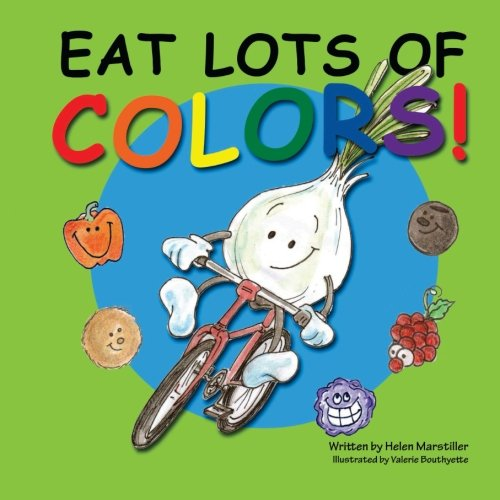What message does the illustrator want to convey through the imagery on this book cover? The illustrator, Valerie Bouttevette, intends to convey a message of joy and excitement associated with healthy eating. The lively and colorful illustrations of fruits and vegetables aim to attract a child's attention and associate positive feelings with consuming a diverse, colorful diet. 